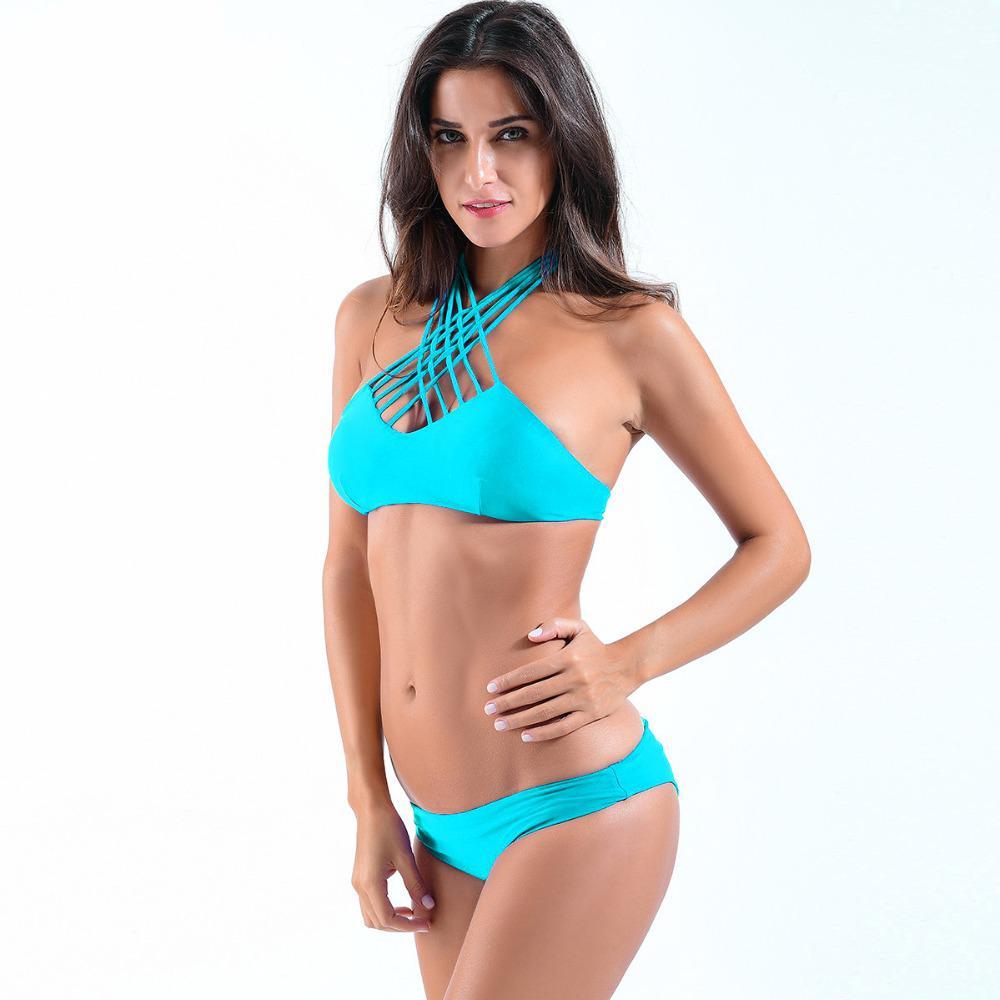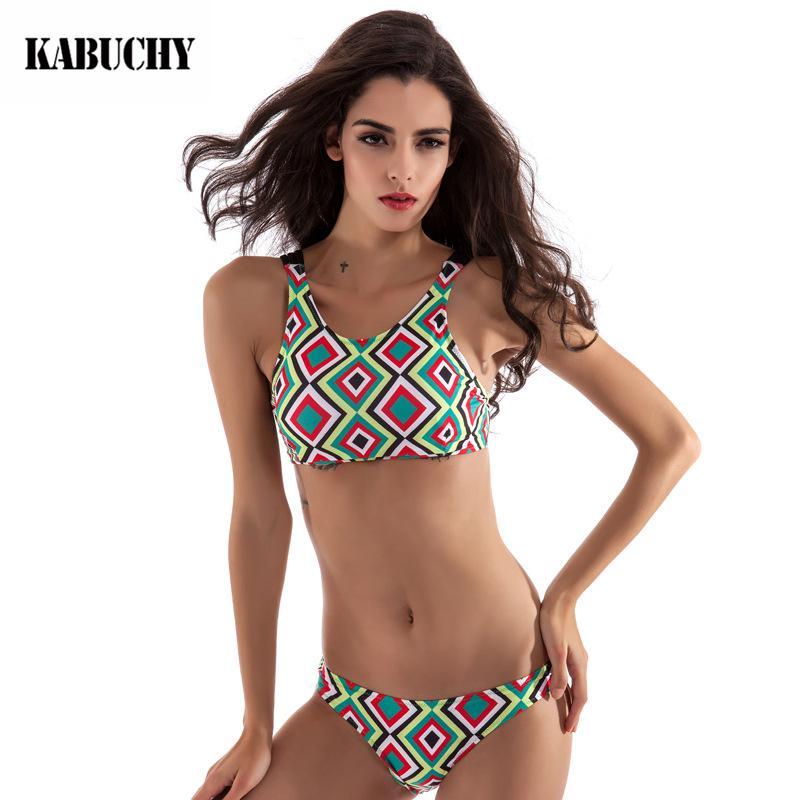The first image is the image on the left, the second image is the image on the right. Examine the images to the left and right. Is the description "At least one model wears a bikini with completely different patterns on the top and bottom." accurate? Answer yes or no. No. 